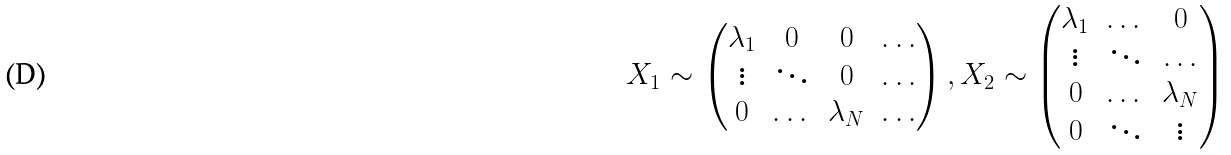<formula> <loc_0><loc_0><loc_500><loc_500>X _ { 1 } \sim \begin{pmatrix} \lambda _ { 1 } & 0 & 0 & \dots \\ \vdots & \ddots & 0 & \dots \\ 0 & \dots & \lambda _ { N } & \dots \end{pmatrix} , X _ { 2 } \sim \begin{pmatrix} \lambda _ { 1 } & \dots & 0 \\ \vdots & \ddots & \dots \\ 0 & \dots & \lambda _ { N } \\ 0 & \ddots & \vdots \end{pmatrix}</formula> 